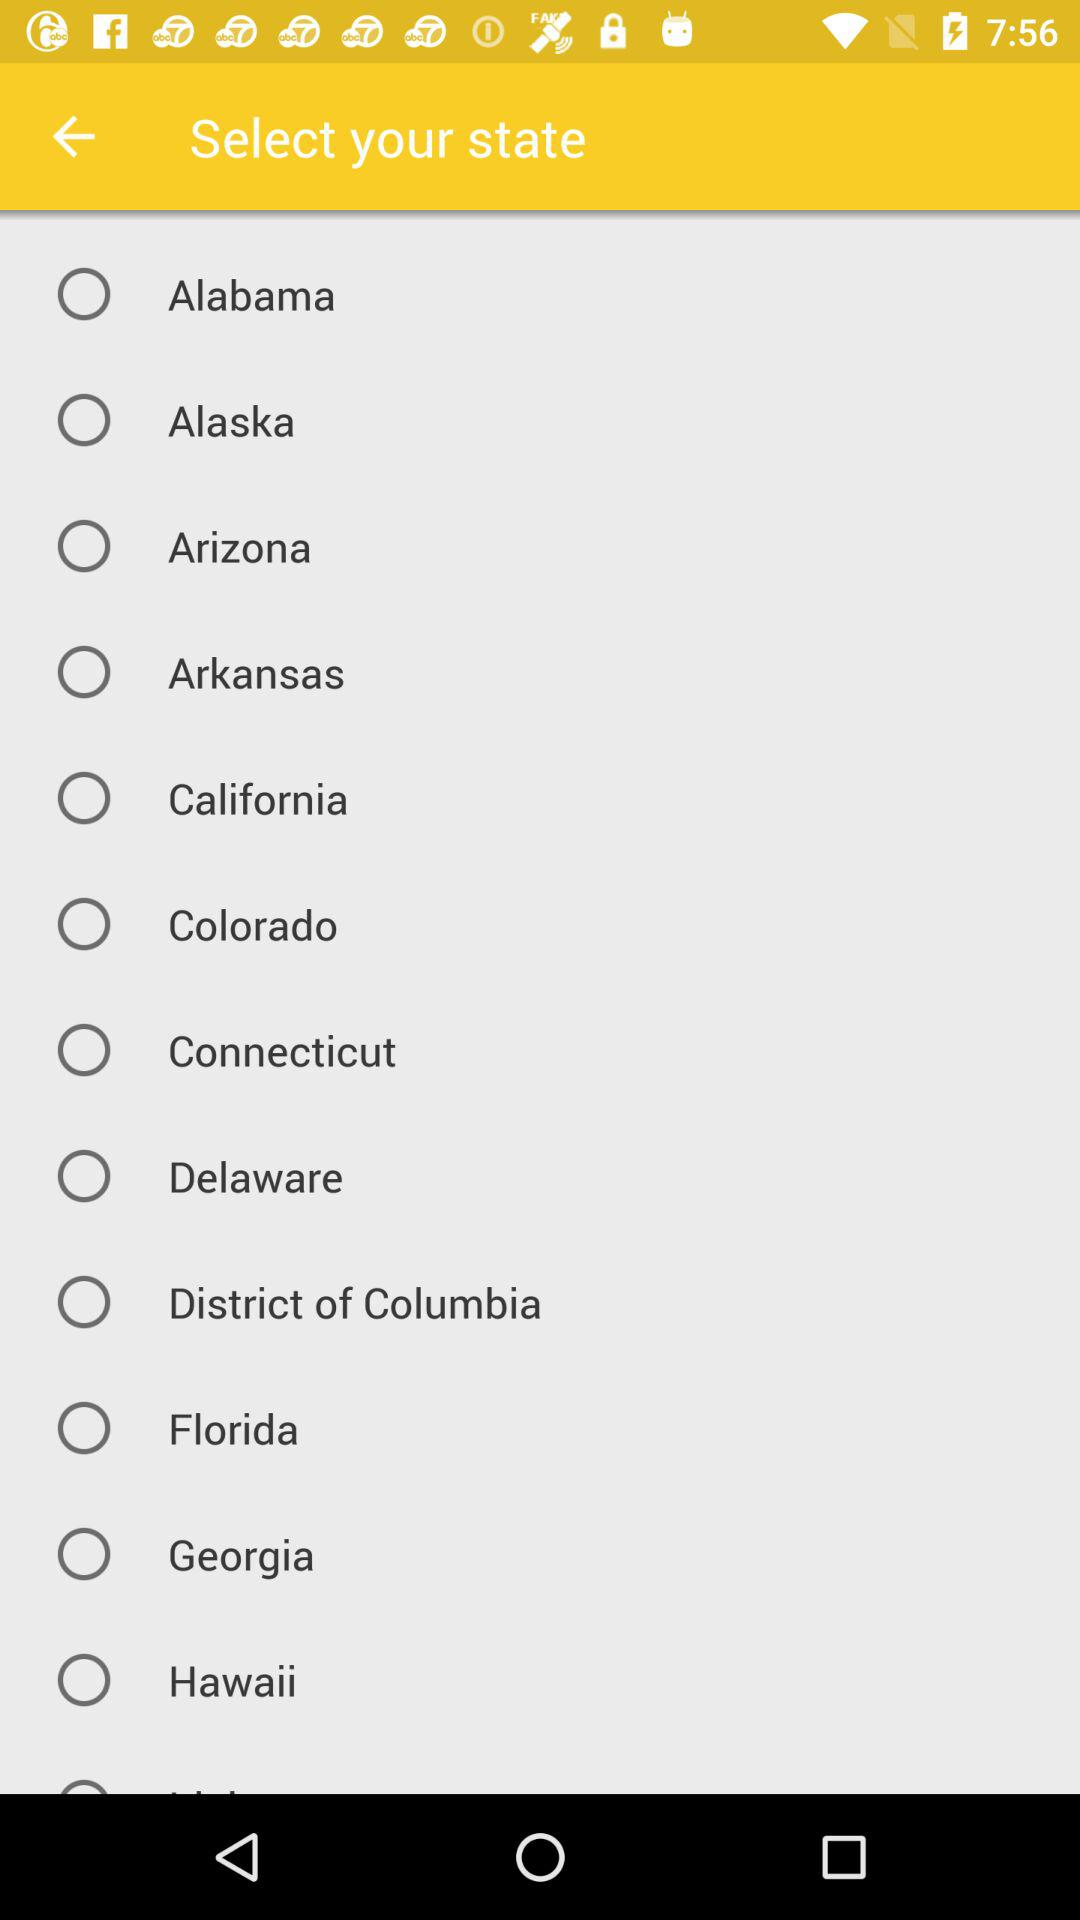Is "Arizona" selected or not? "Arizona" is not selected. 